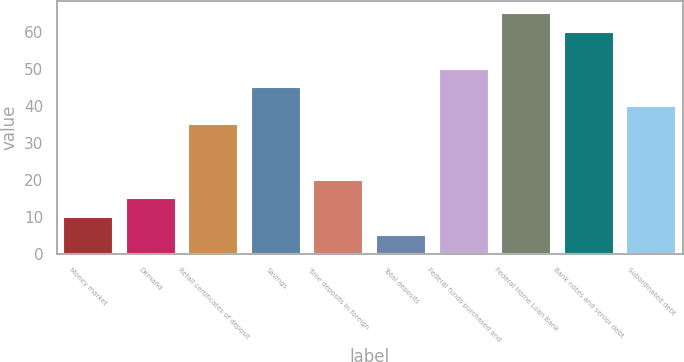<chart> <loc_0><loc_0><loc_500><loc_500><bar_chart><fcel>Money market<fcel>Demand<fcel>Retail certificates of deposit<fcel>Savings<fcel>Time deposits in foreign<fcel>Total deposits<fcel>Federal funds purchased and<fcel>Federal Home Loan Bank<fcel>Bank notes and senior debt<fcel>Subordinated debt<nl><fcel>10<fcel>15<fcel>35<fcel>45<fcel>20<fcel>5<fcel>50<fcel>65<fcel>60<fcel>40<nl></chart> 